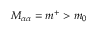<formula> <loc_0><loc_0><loc_500><loc_500>M _ { \alpha \alpha } = m ^ { + } > m _ { 0 }</formula> 